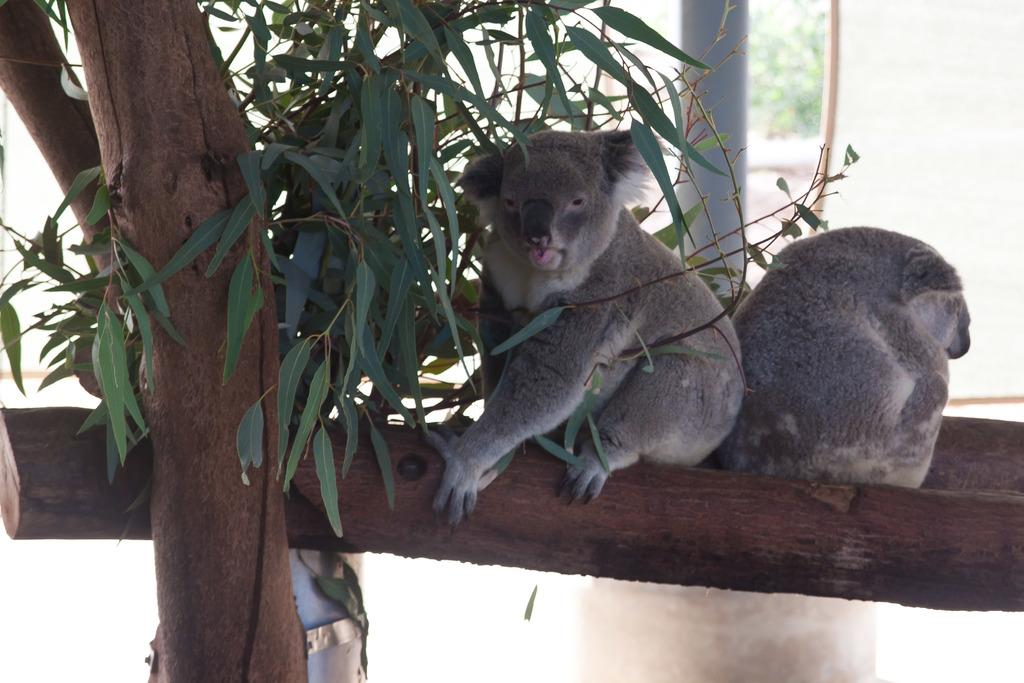What is on the tree branch in the image? There are animals on a tree branch in the image. What else can be seen in the image besides the animals on the branch? There are leaves visible in the image. What can be seen in the background of the image? There is a pole and trees in the background of the image. How would you describe the background of the image? The background appears blurry. Can you see any planes flying in the image? There are no planes visible in the image. Is there a bee buzzing around the animals on the tree branch? There is no bee present in the image. 